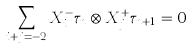Convert formula to latex. <formula><loc_0><loc_0><loc_500><loc_500>\sum _ { i + j = - 2 } X ^ { - } _ { i } \tau _ { n } \otimes X ^ { + } _ { j } \tau _ { n + 1 } = 0</formula> 